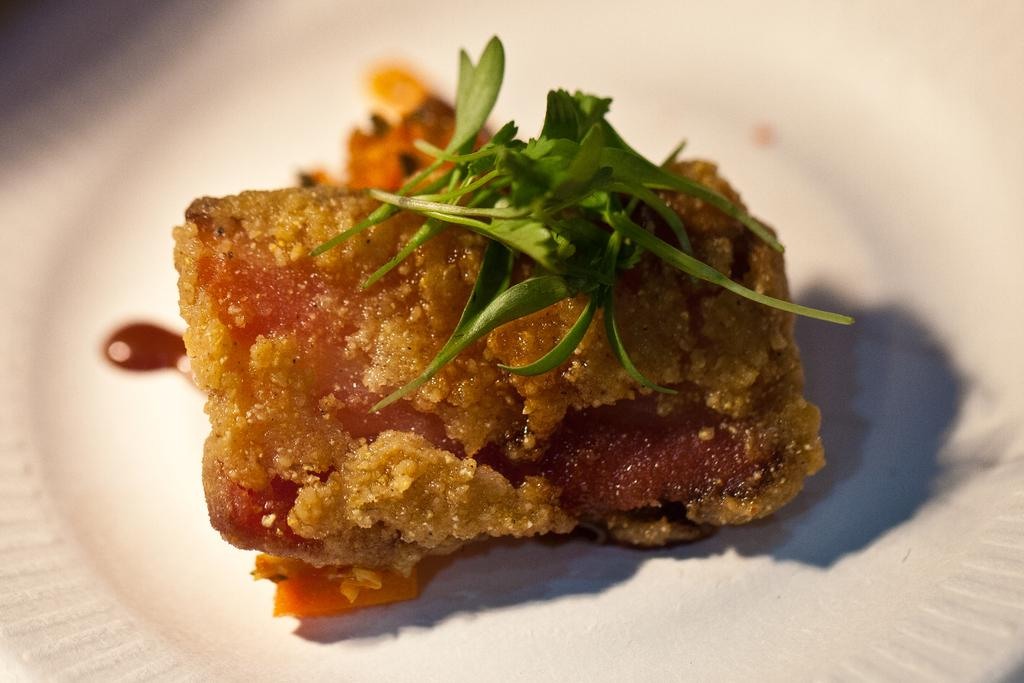What type of location is shown in the image? The image depicts a place. What is the predominant color of the location? The place is predominantly white in color. Can you identify any objects on the plate in the image? There is a plate in the image, and there is a food item on the plate. What else is on the plate besides the food item? There are leaves on the plate. Where is the start line for the race in the image? There is no race or start line present in the image; it depicts a place with a plate, food item, and leaves. 